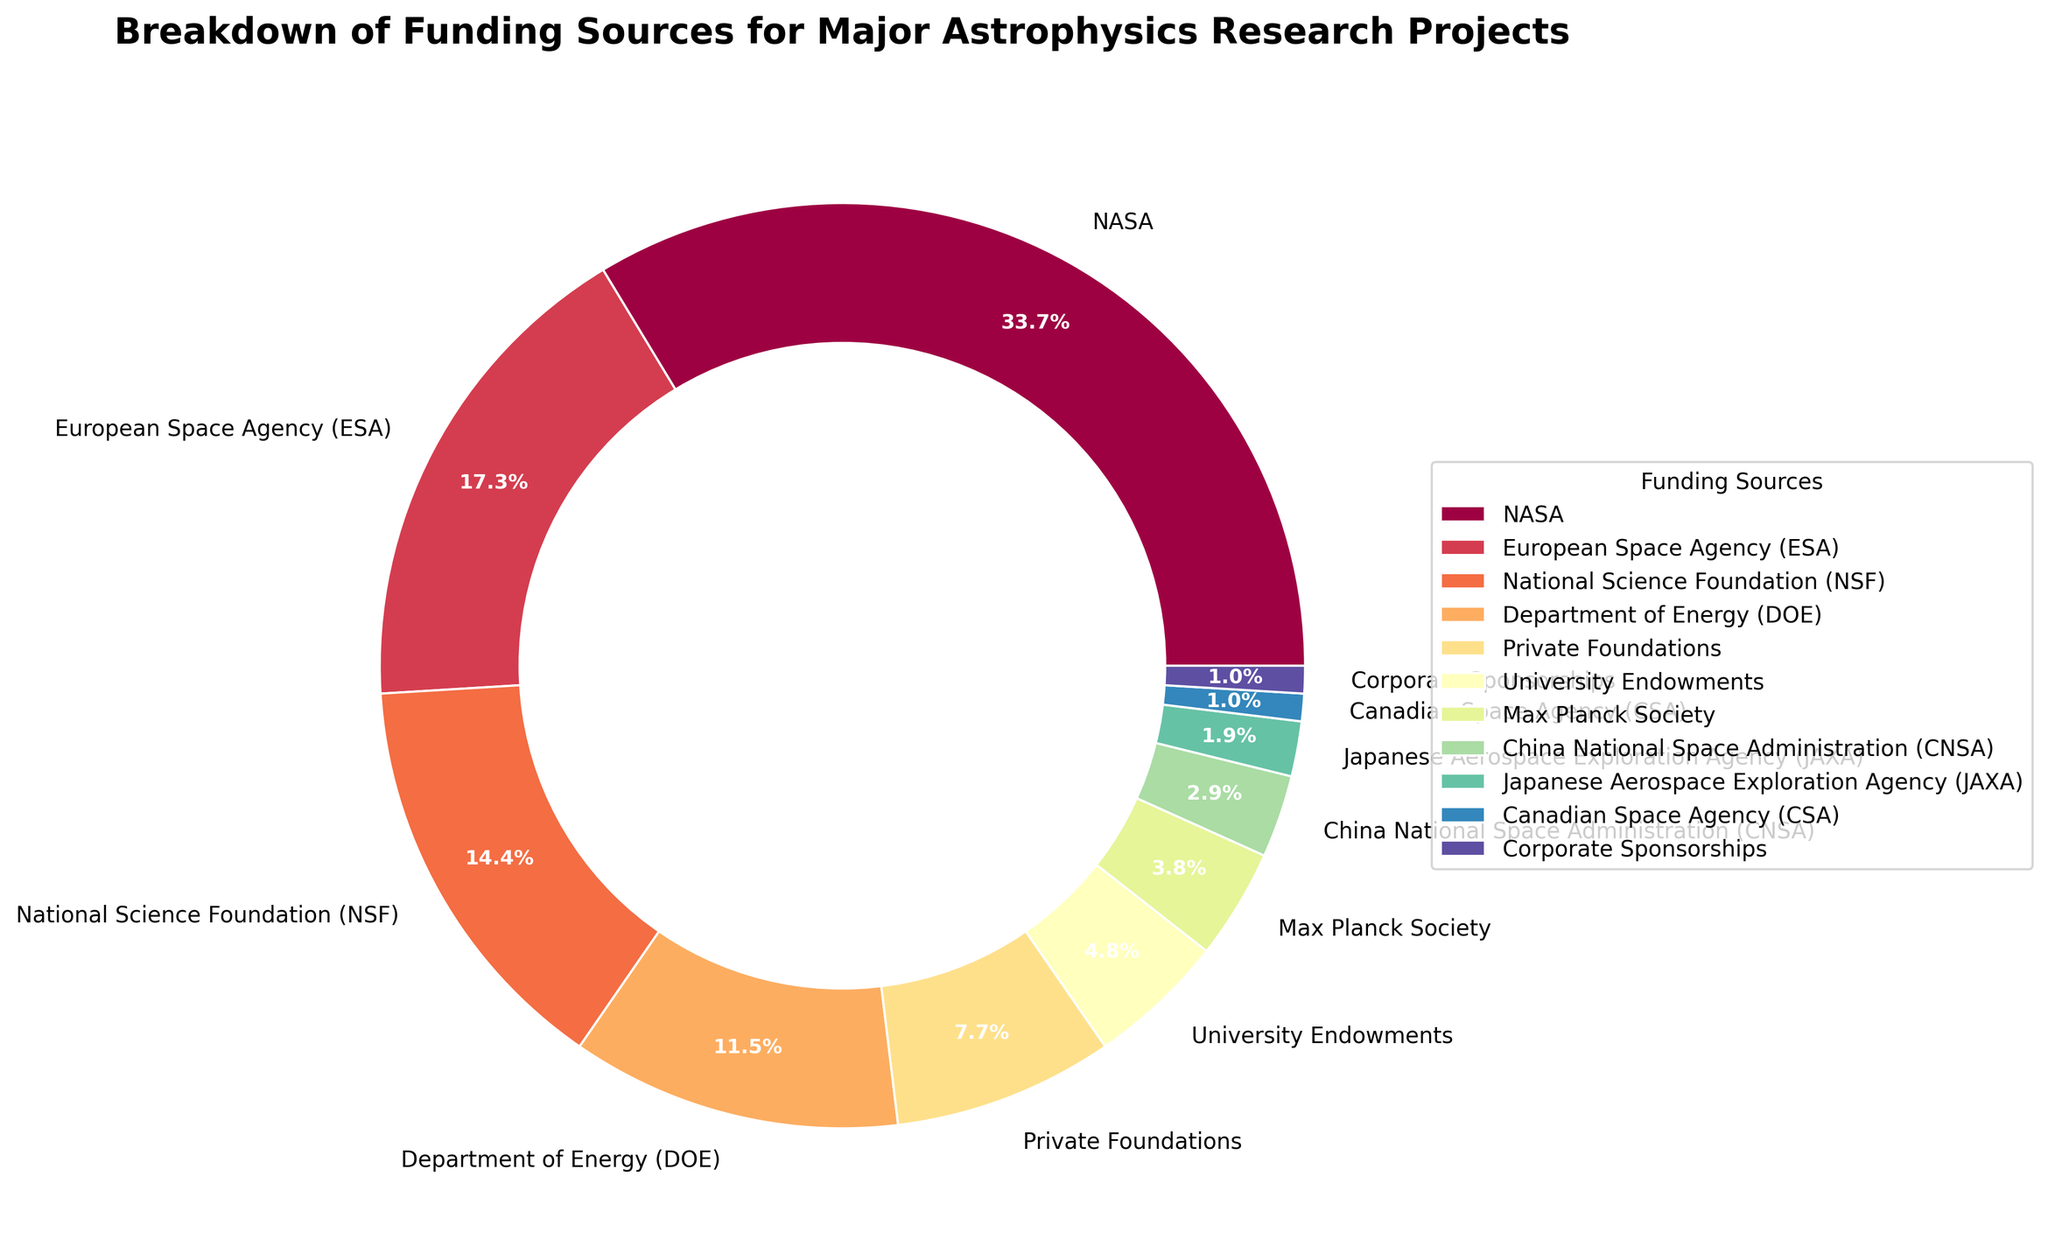Which funding source contributes the most to major astrophysics research projects? By visually inspecting the pie chart, we can determine the largest segment, which is clearly labeled. The largest segment corresponds to NASA.
Answer: NASA Which two funding sources contribute equally to major astrophysics research projects? By looking at the pie chart, we can see that both Corporate Sponsorships and the Canadian Space Agency (CSA) have the same percentage.
Answer: Corporate Sponsorships and CSA How much more does NASA contribute compared to the National Science Foundation (NSF)? From the pie chart, NASA contributes 35%, and NSF contributes 15%. Subtracting these values gives the difference: 35% - 15% = 20%.
Answer: 20% What is the combined contribution percentage of the European Space Agency (ESA) and the Department of Energy (DOE)? The pie chart shows that ESA contributes 18% and DOE contributes 12%. Summing these values gives the total: 18% + 12% = 30%.
Answer: 30% Which funding source contributes the least, and what is its percentage? By observing the smallest segment in the pie chart, we can see that the smallest contribution comes from Corporate Sponsorships, with a percentage of 1%.
Answer: Corporate Sponsorships, 1% Are there more contributions from Private Foundations and University Endowments together than from the National Science Foundation (NSF)? Private Foundations contribute 8% and University Endowments contribute 5%, giving a total of 8% + 5% = 13%. NSF contributes 15%. We compare these values: 13% (Private Foundations + University Endowments) is less than 15% (NSF).
Answer: No What is the total contribution percentage of NASA, ESA, and NSF? Adding their contributions from the pie chart: NASA (35%) + ESA (18%) + NSF (15%) equals 68%.
Answer: 68% Which funding sources combined contribute the same as NASA alone? We need to identify segments that sum to NASA's contribution of 35%. Private Foundations (8%) + University Endowments (5%) + Max Planck Society (4%) + China National Space Administration (3%) + Japanese Aerospace Exploration Agency (JAXA) (2%) + Canadian Space Agency (CSA) (1%) + Corporate Sponsorships (1%) together equal 8% + 5% + 4% + 3% + 2% + 1% + 1% = 24%. This is less than NASA. Next, combining DOE (12%) + Private Foundations (8%) + University Endowments (5%) + Max Planck Society (4%) + China National Space Administration (3%) + Japanese Aerospace Exploration Agency (JAXA) (2%) + Canadian Space Agency (CSA) (1%) + Corporate Sponsorships (1%) sums to 12% + 8% + 5% + 4% + 3% + 2% + 1% + 1% = 36%. This is closest to NASA's 35%.
Answer: DOE, Private Foundations, University Endowments, Max Planck Society, CNSA, JAXA, CSA, Corporate Sponsorships What percentage do governmental agencies (NASA, ESA, NSF, DOE, CNSA, JAXA, CSA) contribute together? Summing the contributions from all the listed governmental agencies: NASA (35%) + ESA (18%) + NSF (15%) + DOE (12%) + CNSA (3%) + JAXA (2%) + CSA (1%) equals 86%.
Answer: 86% How much more do governmental agencies contribute compared to non-governmental sources (Private Foundations, University Endowments, Corporate Sponsorships, and Max Planck Society)? First, sum the percentages of non-governmental sources: Private Foundations (8%) + University Endowments (5%) + Max Planck Society (4%) + Corporate Sponsorships (1%) equals 18%. Then subtract this sum from the total contribution of governmental agencies: 86% (governmental) - 18% (non-governmental) = 68%.
Answer: 68% 